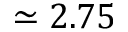Convert formula to latex. <formula><loc_0><loc_0><loc_500><loc_500>\simeq 2 . 7 5</formula> 